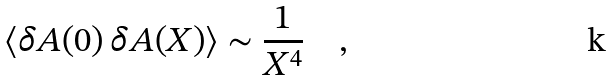Convert formula to latex. <formula><loc_0><loc_0><loc_500><loc_500>\langle \delta A ( 0 ) \, \delta A ( X ) \rangle \sim \frac { 1 } { X ^ { 4 } } \quad ,</formula> 